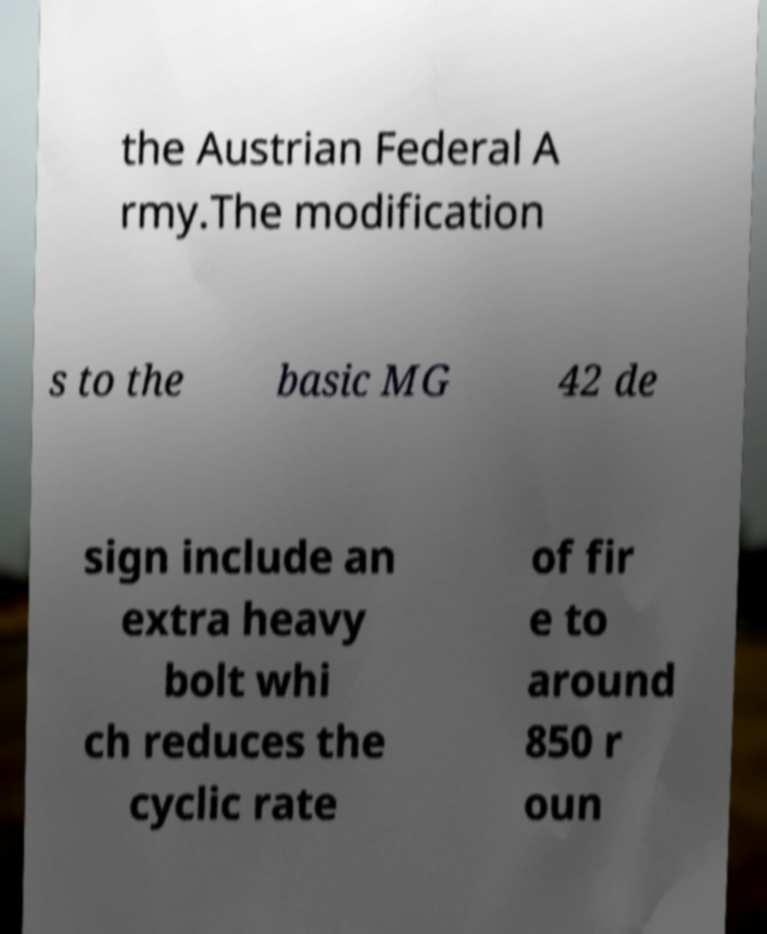Please identify and transcribe the text found in this image. the Austrian Federal A rmy.The modification s to the basic MG 42 de sign include an extra heavy bolt whi ch reduces the cyclic rate of fir e to around 850 r oun 